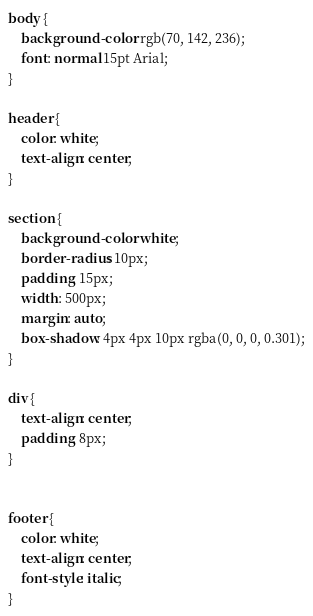<code> <loc_0><loc_0><loc_500><loc_500><_CSS_>body {
    background-color: rgb(70, 142, 236);
    font: normal 15pt Arial;
}

header {
    color: white;
    text-align: center;
}

section {
    background-color: white;
    border-radius: 10px;
    padding: 15px;
    width: 500px;
    margin: auto;
    box-shadow: 4px 4px 10px rgba(0, 0, 0, 0.301);
}

div {
    text-align: center;
    padding: 8px;
}


footer {
    color: white;
    text-align: center;
    font-style: italic;
}</code> 